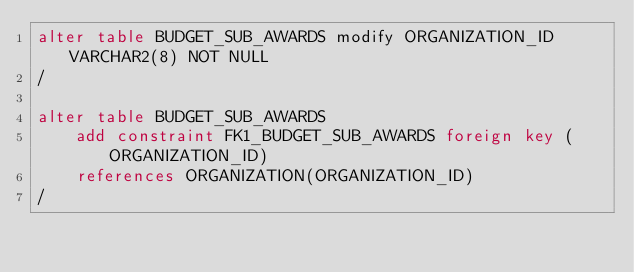<code> <loc_0><loc_0><loc_500><loc_500><_SQL_>alter table BUDGET_SUB_AWARDS modify ORGANIZATION_ID VARCHAR2(8) NOT NULL
/

alter table BUDGET_SUB_AWARDS
	add constraint FK1_BUDGET_SUB_AWARDS foreign key (ORGANIZATION_ID)
	references ORGANIZATION(ORGANIZATION_ID)
/
</code> 